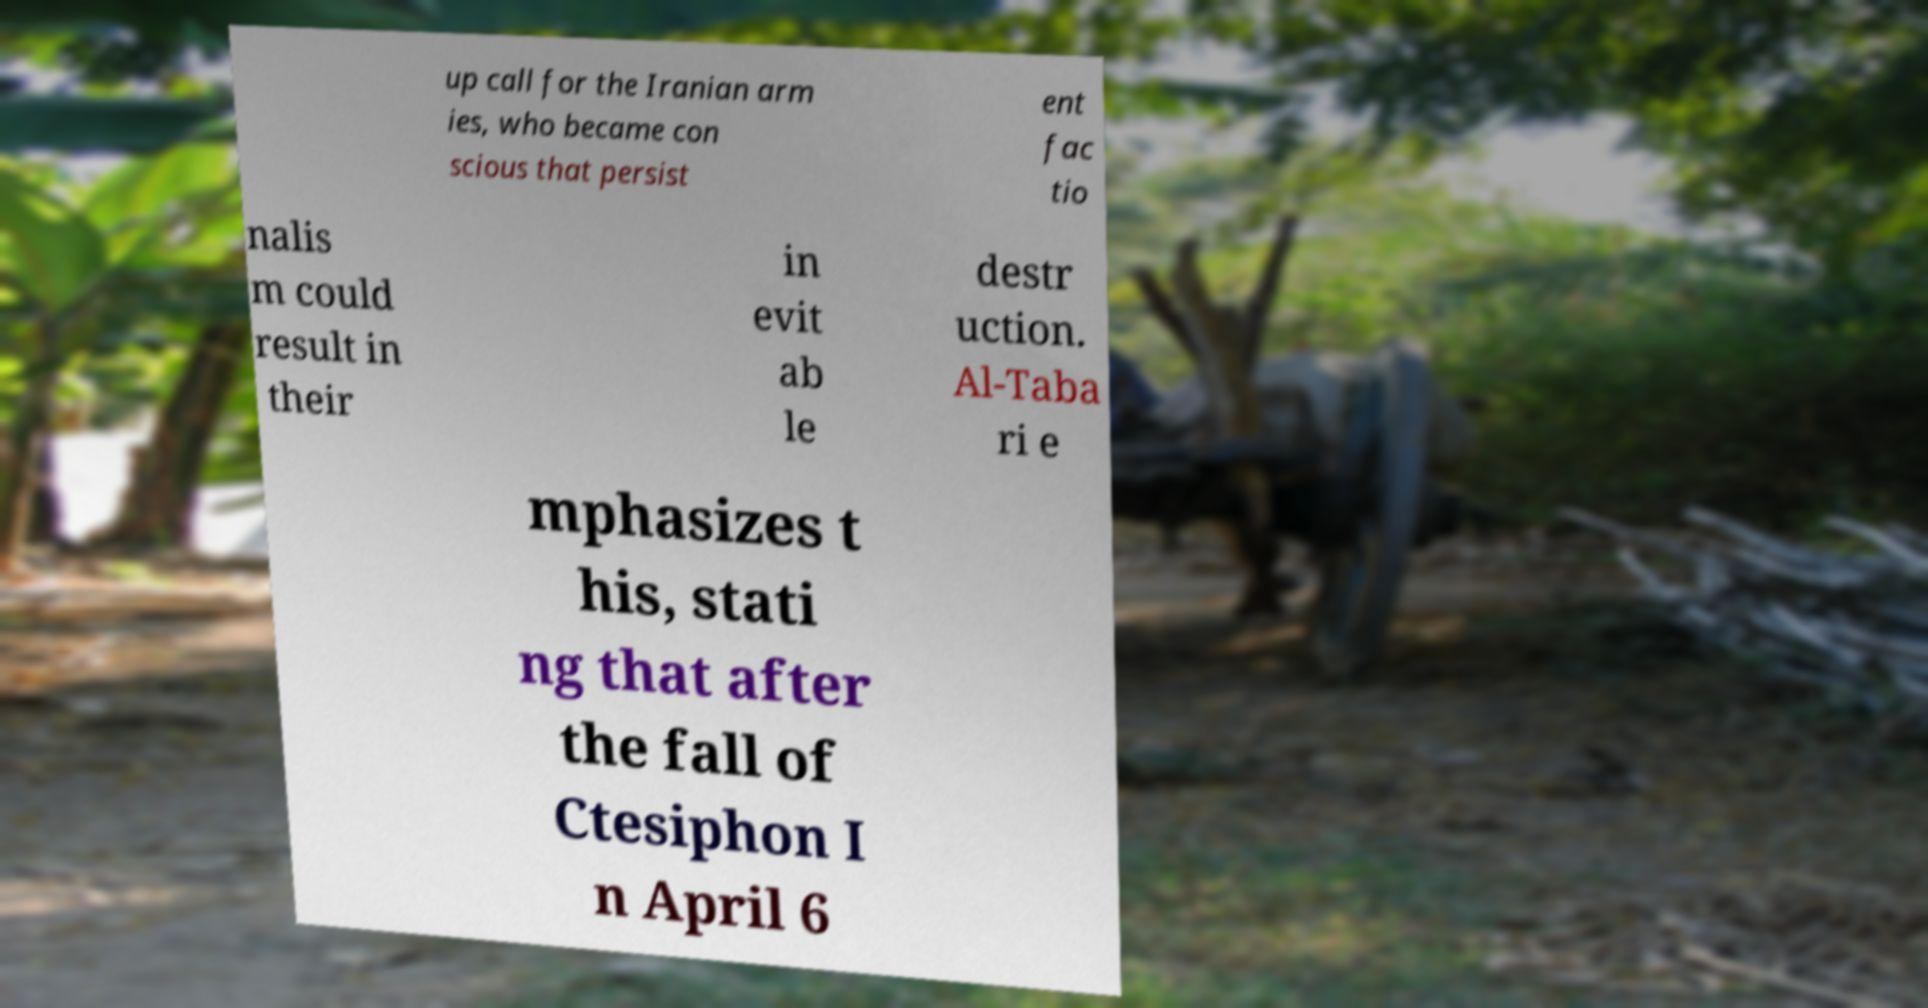I need the written content from this picture converted into text. Can you do that? up call for the Iranian arm ies, who became con scious that persist ent fac tio nalis m could result in their in evit ab le destr uction. Al-Taba ri e mphasizes t his, stati ng that after the fall of Ctesiphon I n April 6 